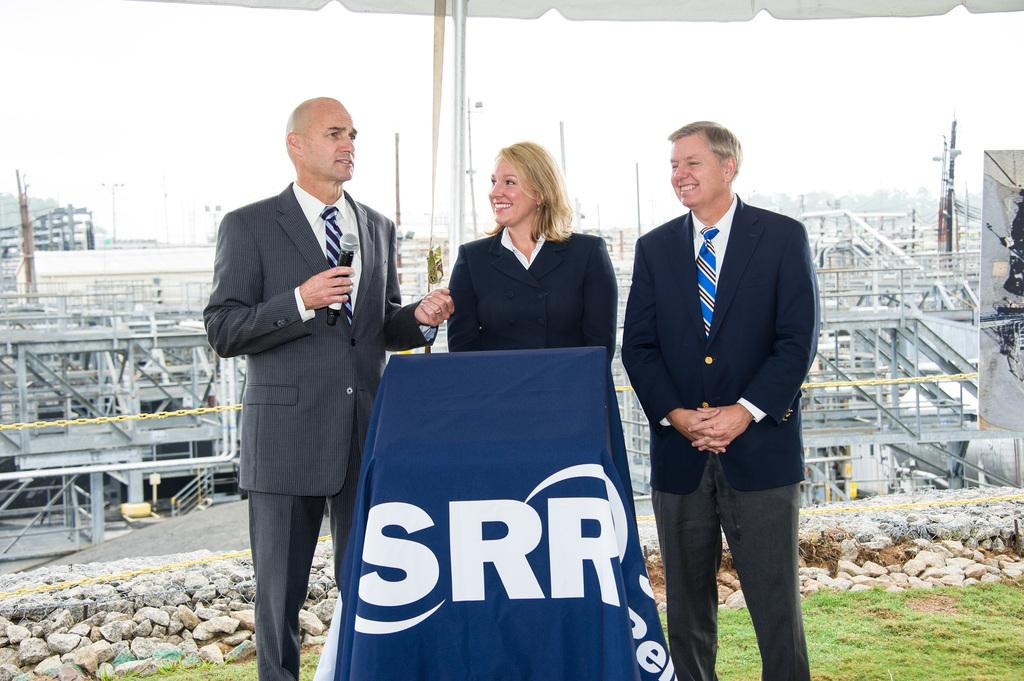<image>
Render a clear and concise summary of the photo. an SRR podium with three people behind it 